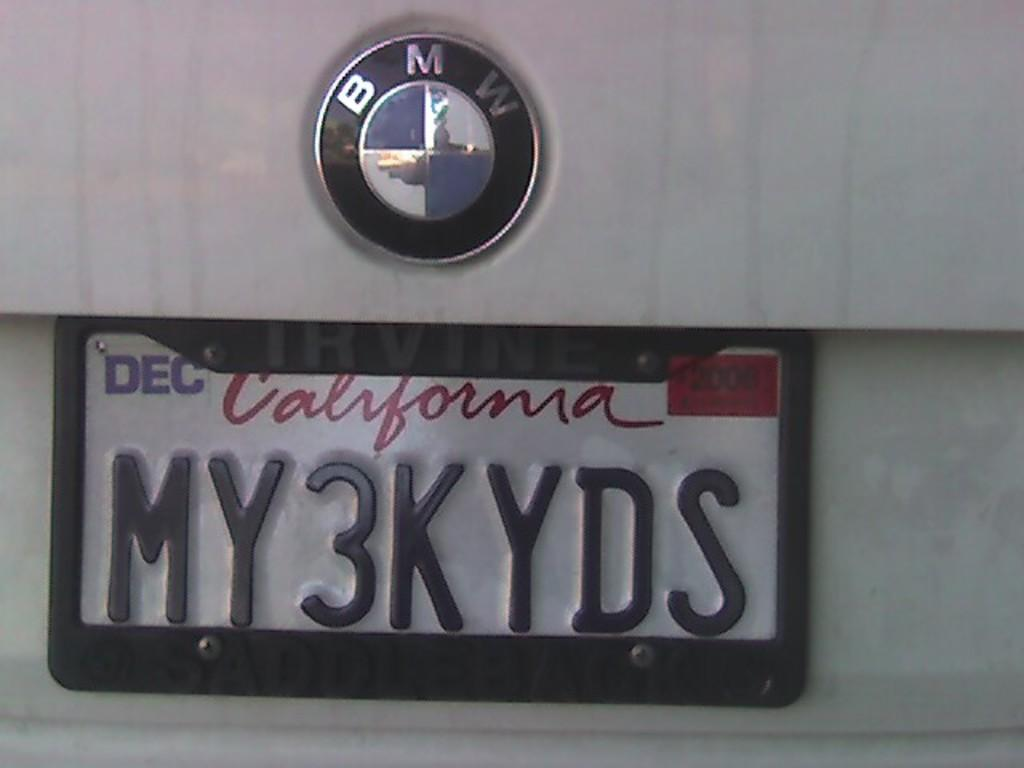What brand logo is visible in the image? There is a BMW logo in the image. What other identifying feature can be seen on the vehicle in the image? There is a number plate on the vehicle in the image. How many bones are visible in the image? There are no bones present in the image. What is the fifth element in the image? The provided facts do not mention a fifth element in the image, so it cannot be determined. 